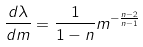<formula> <loc_0><loc_0><loc_500><loc_500>\frac { d \lambda } { d m } = \frac { 1 } { 1 - n } m ^ { - \frac { n - 2 } { n - 1 } }</formula> 